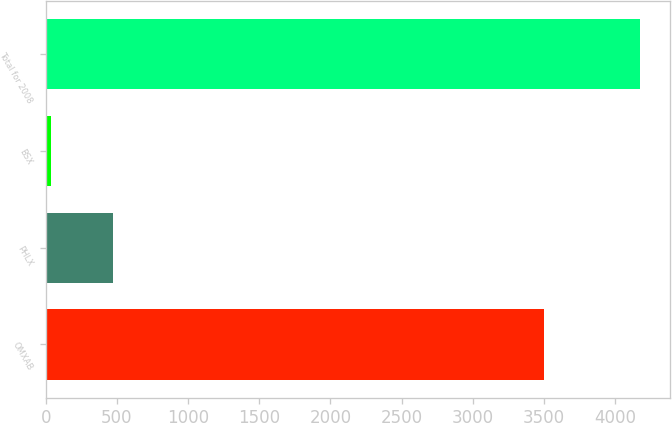<chart> <loc_0><loc_0><loc_500><loc_500><bar_chart><fcel>OMXAB<fcel>PHLX<fcel>BSX<fcel>Total for 2008<nl><fcel>3504<fcel>470<fcel>35<fcel>4177<nl></chart> 